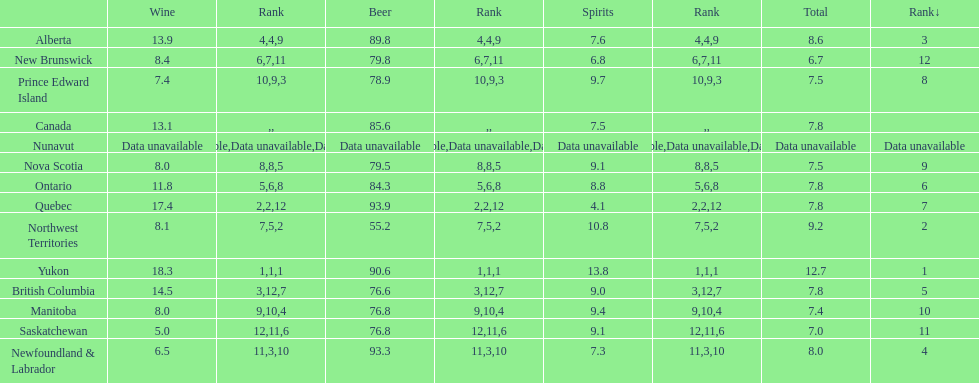Which province is the top consumer of wine? Yukon. 